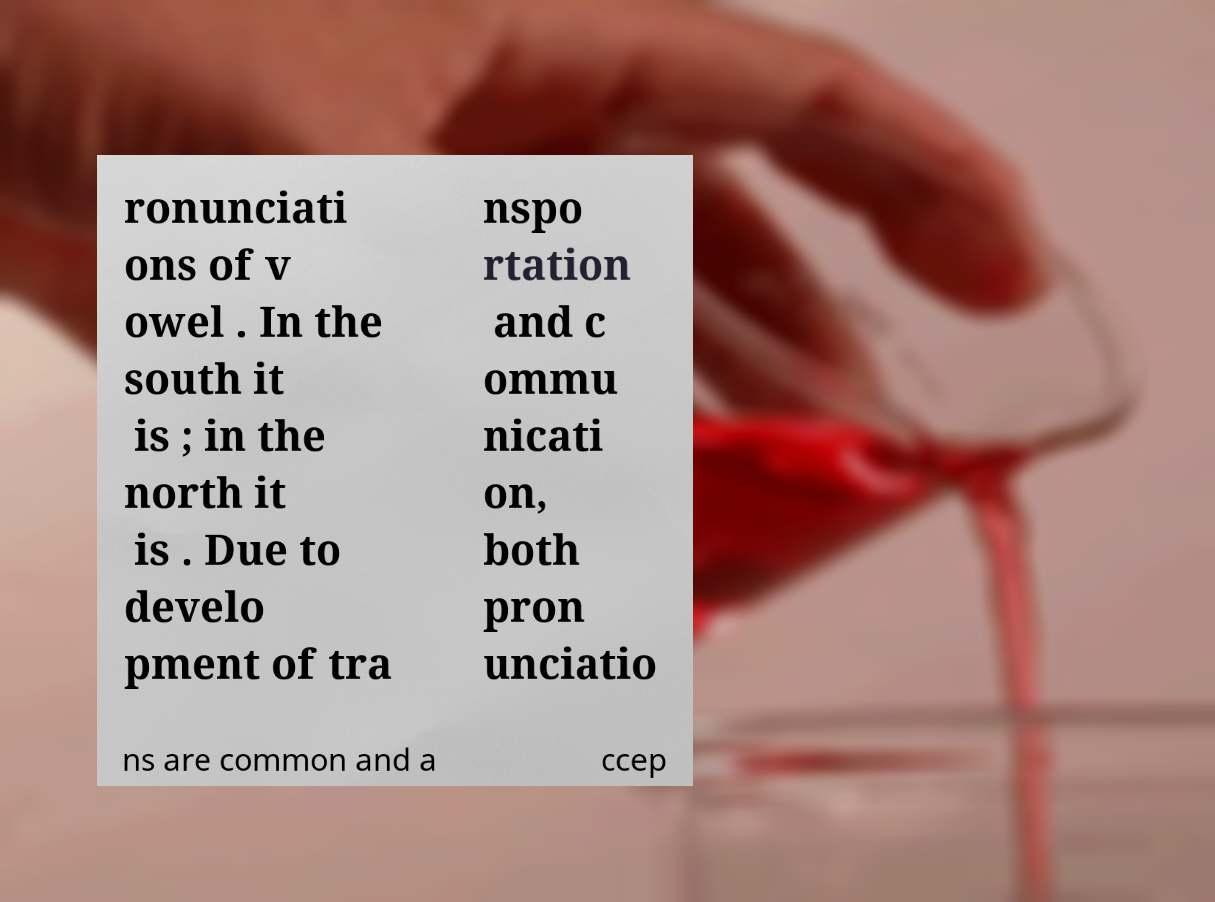There's text embedded in this image that I need extracted. Can you transcribe it verbatim? ronunciati ons of v owel . In the south it is ; in the north it is . Due to develo pment of tra nspo rtation and c ommu nicati on, both pron unciatio ns are common and a ccep 